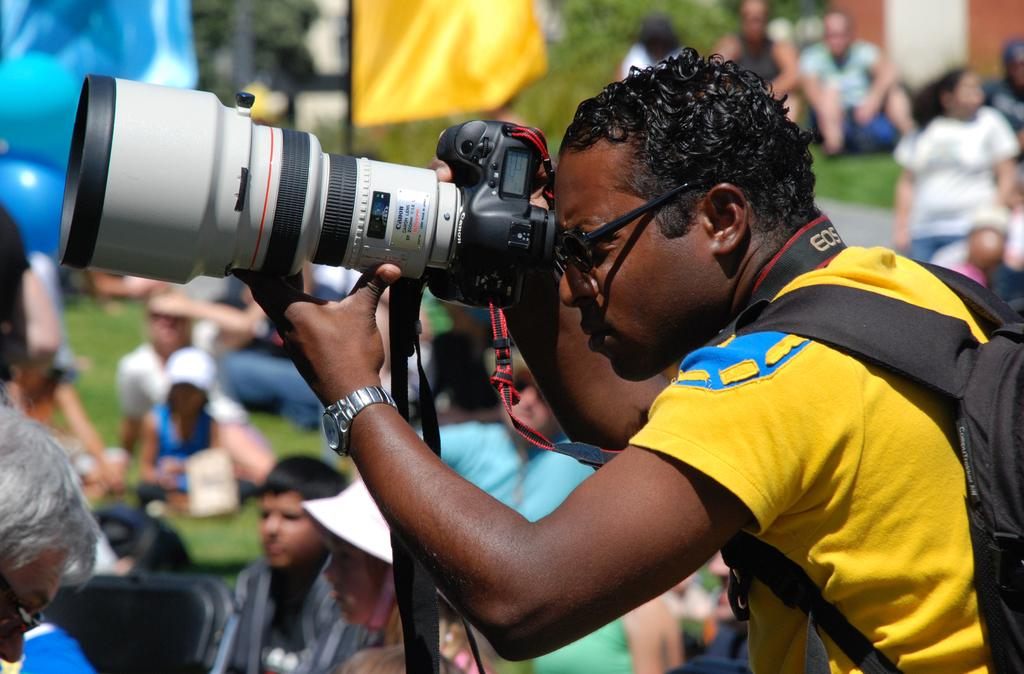What is the man in the image doing? The man is standing in the image and holding a camera. What object is present in the image that represents a country or organization? There is a flag in the image. What are the people in the image doing? The people are sitting in the image. Where are the people sitting in relation to the flag? The people are sitting beside the flag. What type of peace symbol can be seen in the image? There is no peace symbol present in the image. What type of coil is wrapped around the flag in the image? There is no coil present in the image, and the flag is not wrapped around anything. What type of quilt is being used as a background in the image? There is no quilt present in the image; it features a man holding a camera, a flag, and people sitting beside the flag. 